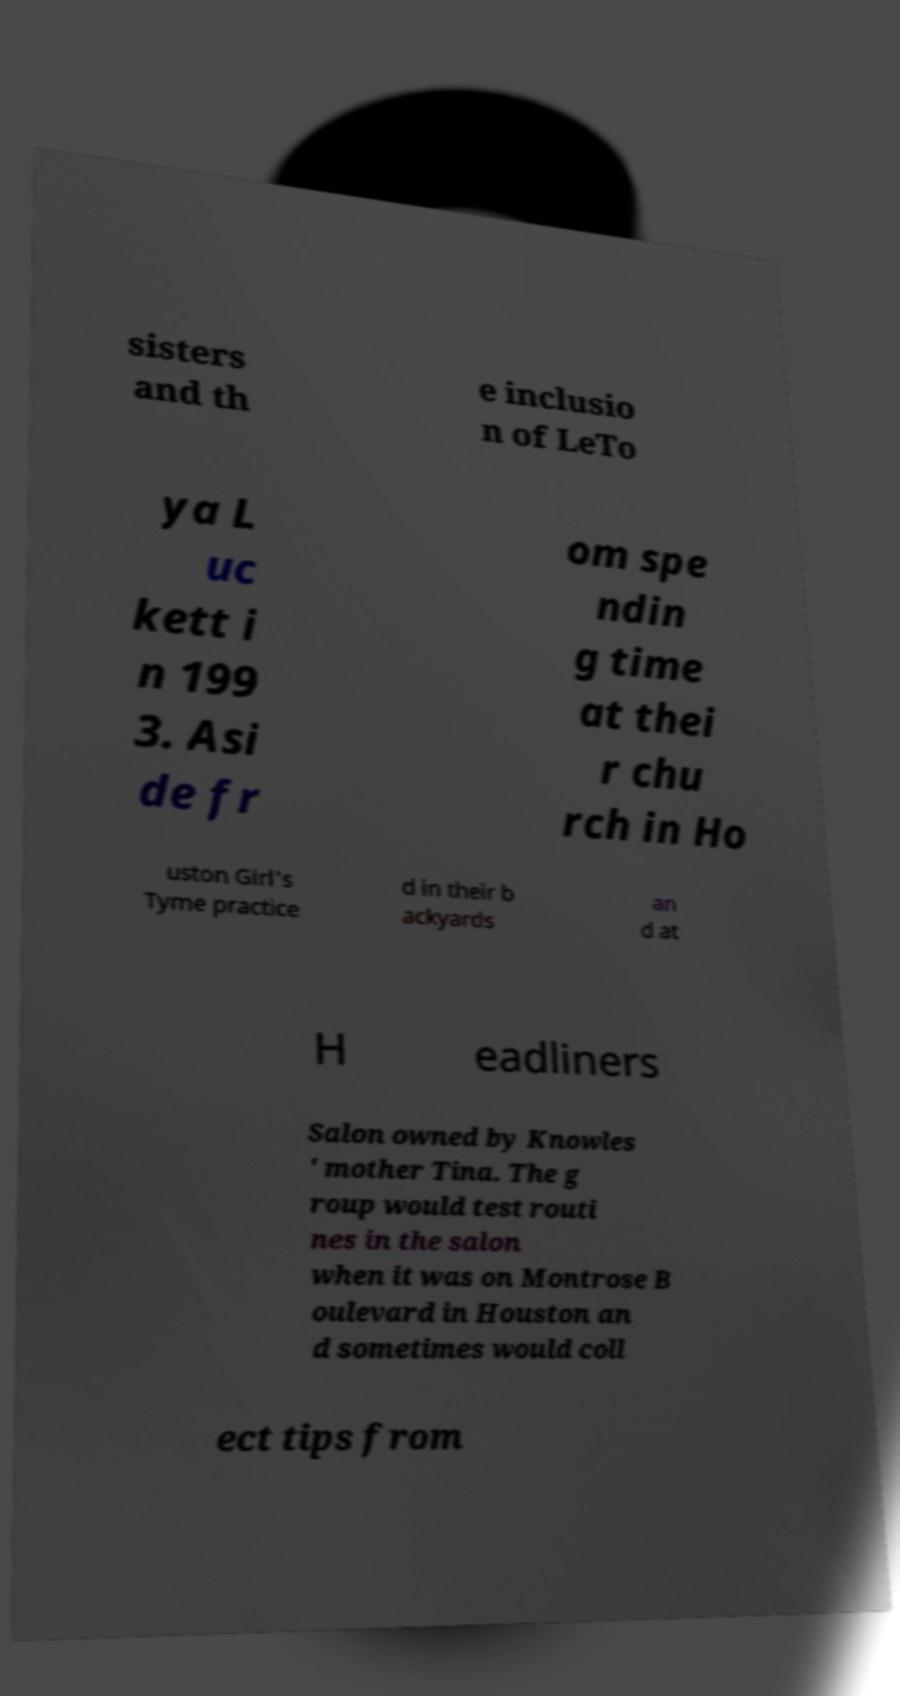I need the written content from this picture converted into text. Can you do that? sisters and th e inclusio n of LeTo ya L uc kett i n 199 3. Asi de fr om spe ndin g time at thei r chu rch in Ho uston Girl's Tyme practice d in their b ackyards an d at H eadliners Salon owned by Knowles ' mother Tina. The g roup would test routi nes in the salon when it was on Montrose B oulevard in Houston an d sometimes would coll ect tips from 